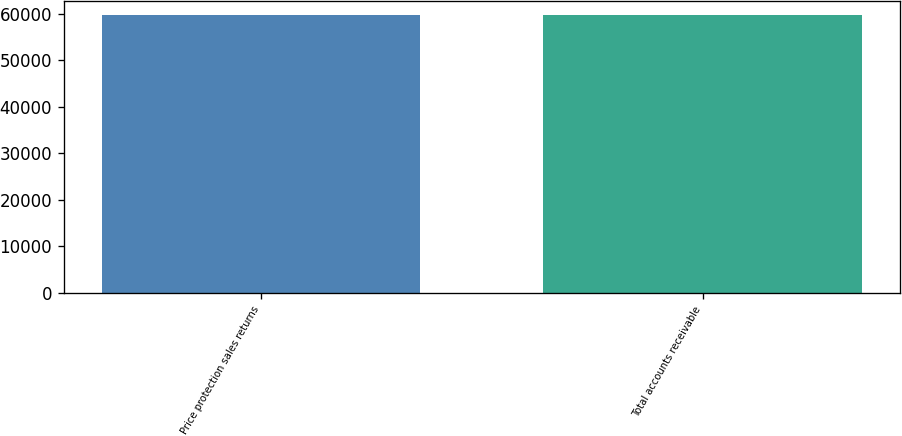Convert chart. <chart><loc_0><loc_0><loc_500><loc_500><bar_chart><fcel>Price protection sales returns<fcel>Total accounts receivable<nl><fcel>59674<fcel>59674.1<nl></chart> 